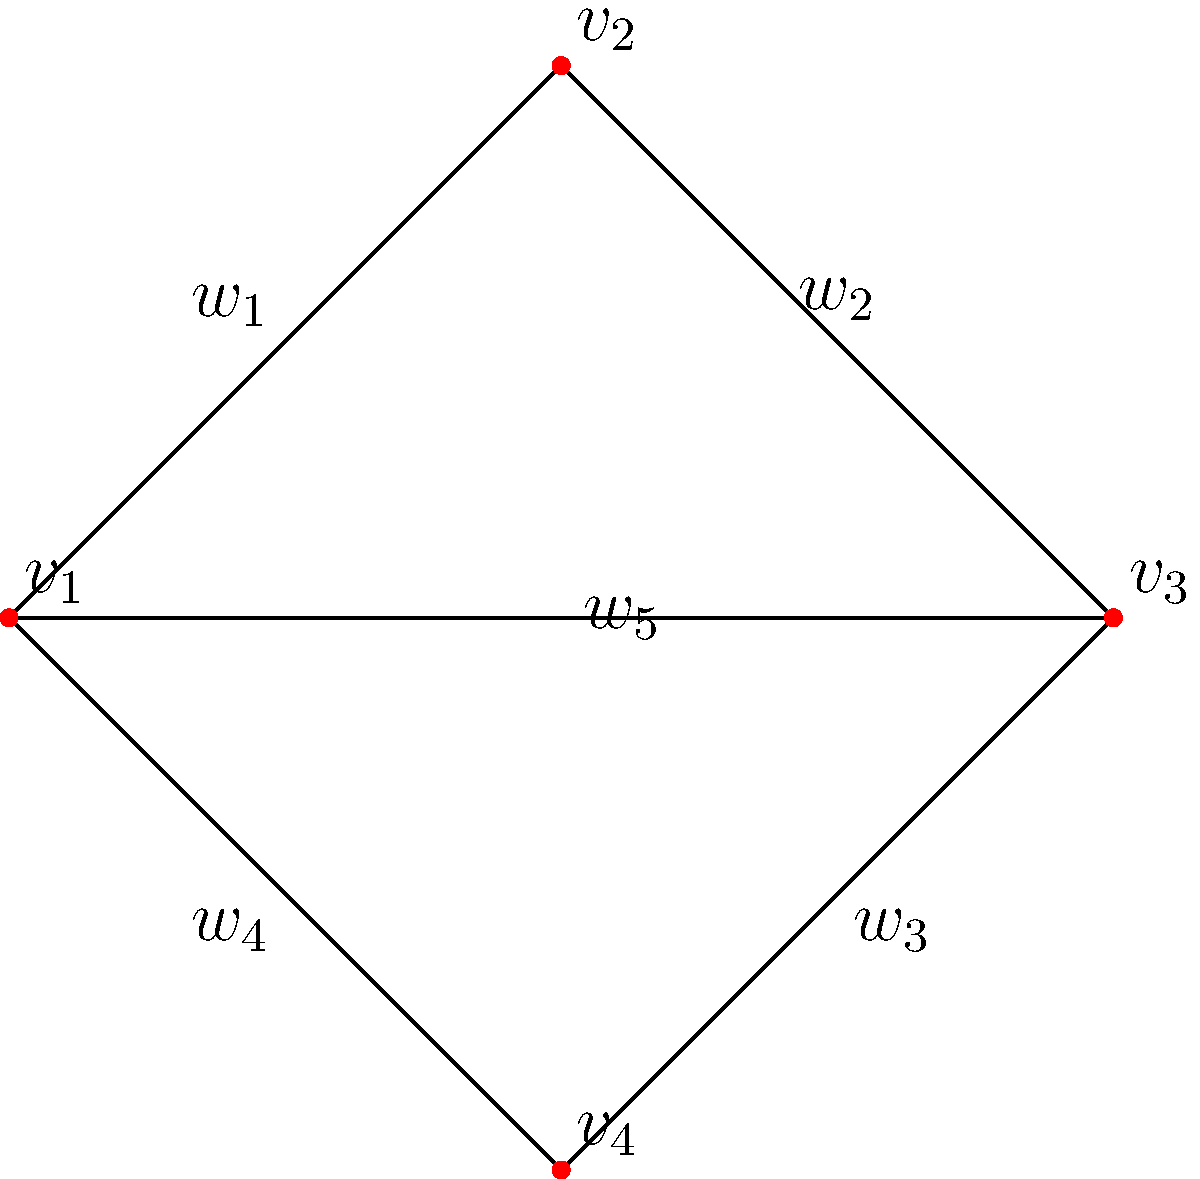In a computational fluid dynamics simulation, fluid particles are modeled as vertices in a graph, with edges representing interactions between particles. Given the graph above, where vertices represent fluid particles and edge weights represent interaction strengths, what is the minimum number of edges that need to be removed to disconnect the graph, and how does this relate to the resilience of the fluid particle network? To answer this question, we need to follow these steps:

1. Understand the concept of graph connectivity:
   A graph is considered connected if there is a path between every pair of vertices.

2. Identify the minimum cut set:
   The minimum cut set is the smallest set of edges whose removal disconnects the graph.

3. Analyze the graph structure:
   - The graph has 4 vertices ($v_1$, $v_2$, $v_3$, $v_4$) and 5 edges ($w_1$, $w_2$, $w_3$, $w_4$, $w_5$).
   - It forms a complete graph K4 minus one edge (between $v_1$ and $v_3$).

4. Determine the minimum number of edges to remove:
   - Removing any single edge will not disconnect the graph.
   - Removing any two adjacent edges will disconnect the graph.
   - The minimum number of edges to remove is 2.

5. Relate to the resilience of the fluid particle network:
   - The minimum cut size (2) represents the graph's edge connectivity.
   - Higher edge connectivity indicates greater resilience in the fluid particle network.
   - In this case, the network is relatively resilient, as it requires removing at least 2 edges to disconnect it.

6. Interpret in the context of computational fluid dynamics:
   - Each removed edge represents a broken interaction between fluid particles.
   - The network's resilience suggests that the fluid model can maintain connectivity even if some particle interactions are disrupted.
   - This property is important for stable simulations and accurate representation of fluid behavior.
Answer: 2 edges; higher edge connectivity indicates greater network resilience. 